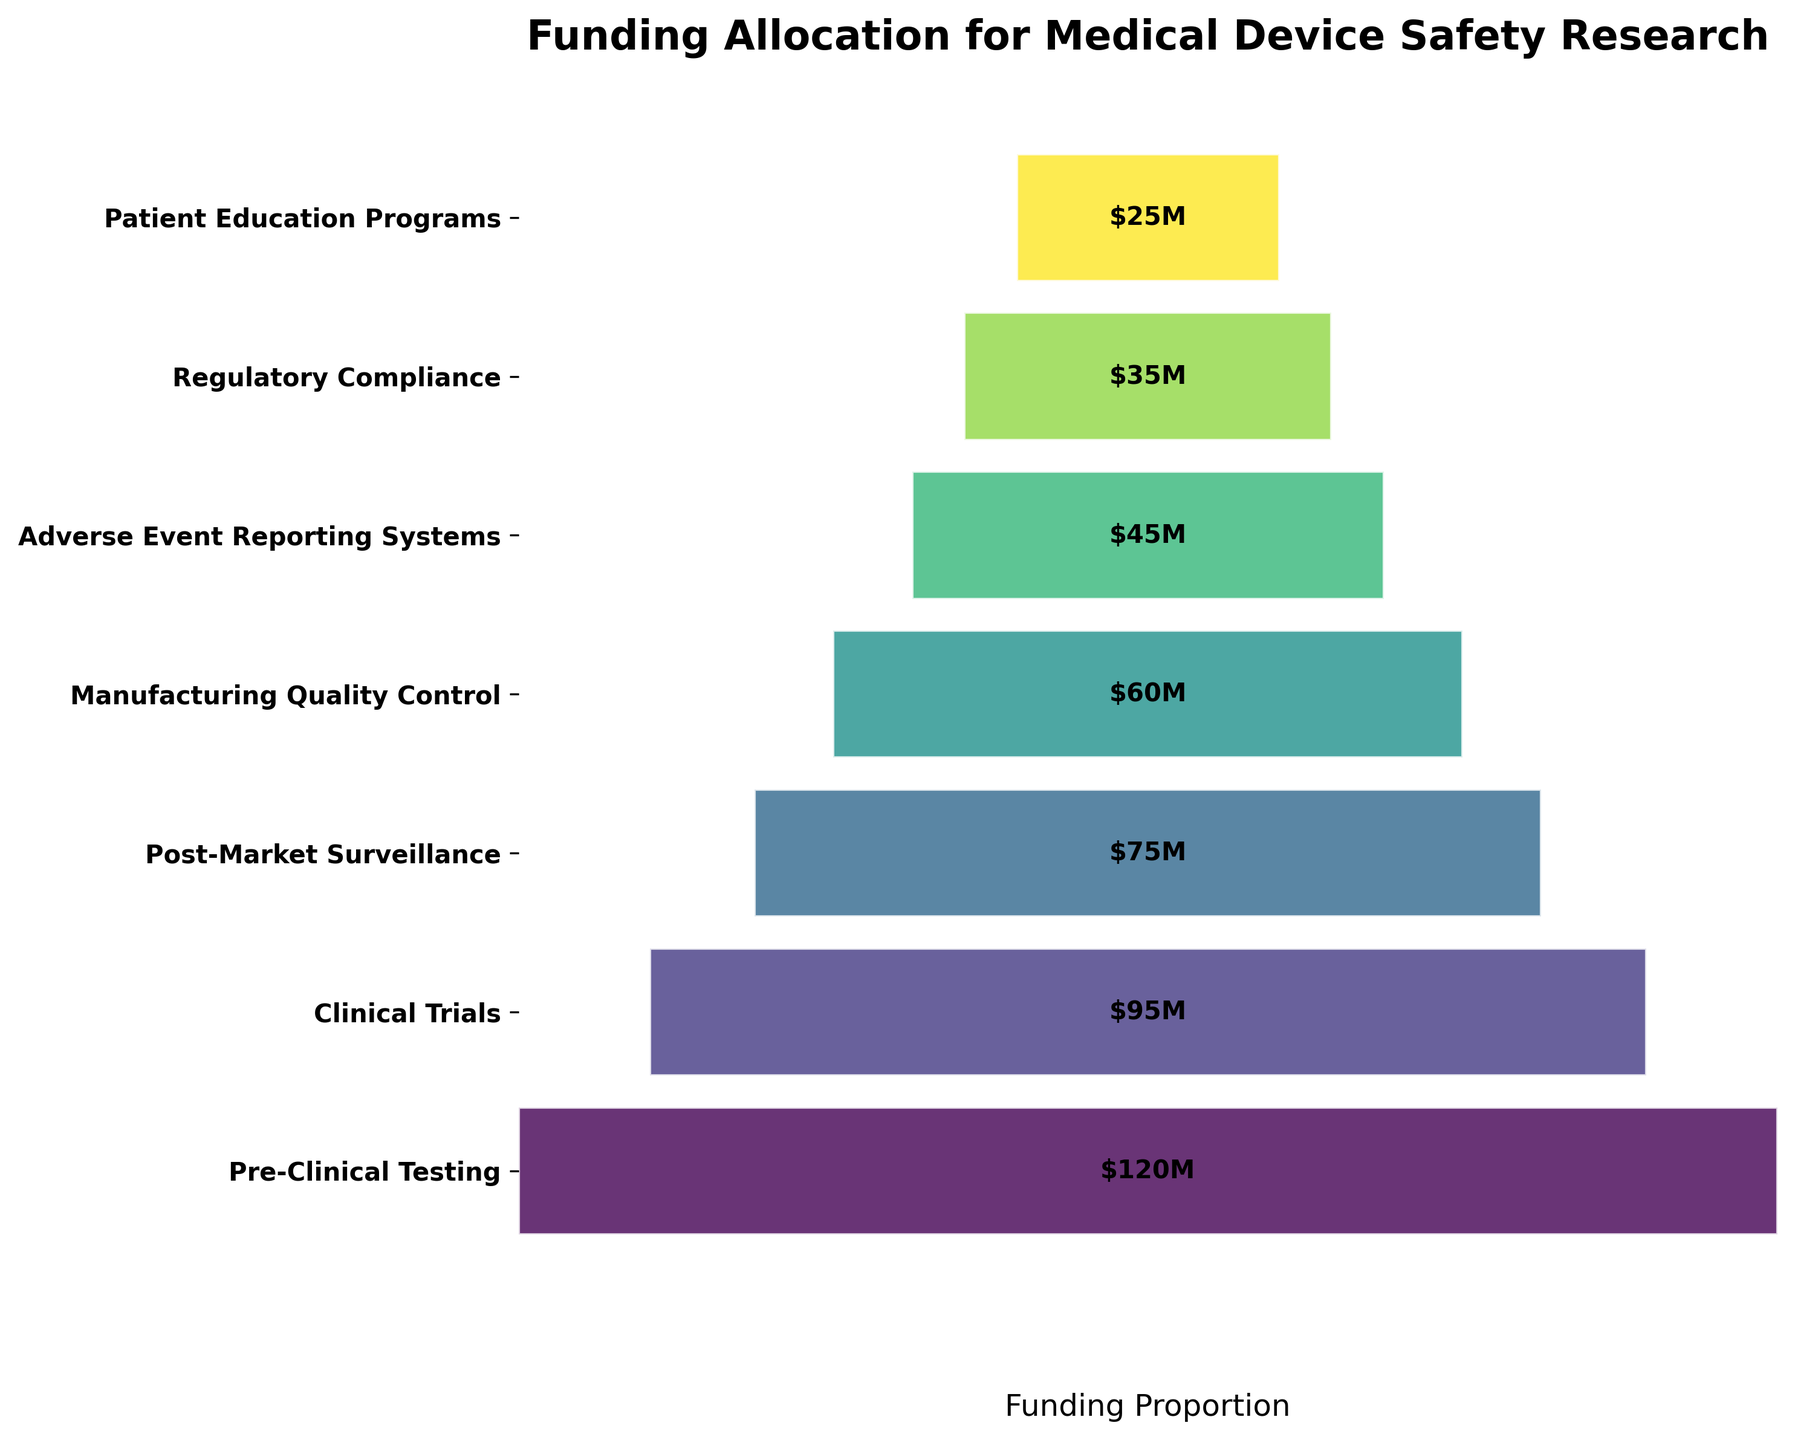What is the title of the figure? The title is usually displayed at the top of the figure. In this case, the title reads "Funding Allocation for Medical Device Safety Research".
Answer: Funding Allocation for Medical Device Safety Research How much funding is allocated for Pre-Clinical Testing? By examining the figure, you can see that Pre-Clinical Testing has a funding allocation labeled directly on the bar. It shows "$120M".
Answer: $120M Which phase has the least amount of funding allocated? Look at the bar with the smallest width and check its label. The smallest bar corresponds to "Patient Education Programs" with a funding of "$25M".
Answer: Patient Education Programs How much more funding is given to Clinical Trials compared to Patient Education Programs? Subtract the funding of Patient Education Programs ($25M) from Clinical Trials ($95M): 95 - 25 is equal to 70.
Answer: $70M Which phases have a funding allocation greater than $50M? Identify bars with values greater than $50M and read the labels. These are "Pre-Clinical Testing" ($120M), "Clinical Trials" ($95M), "Post-Market Surveillance" ($75M), and "Manufacturing Quality Control" ($60M).
Answer: Pre-Clinical Testing, Clinical Trials, Post-Market Surveillance, Manufacturing Quality Control What is the average funding across all phases? First, sum up all the funding values: 120 + 95 + 75 + 60 + 45 + 35 + 25 = 455. Then, divide by the number of phases (7): 455 / 7 = 65.
Answer: $65M Which two phases have a combined funding closest to $100M? Check combinations of funding values to find the pair closest to $100M. "Manufacturing Quality Control" ($60M) and "Adverse Event Reporting Systems" ($45M) sum up to 60 + 45 = 105, which is close to $100M.
Answer: Manufacturing Quality Control and Adverse Event Reporting Systems What is the funding difference between the phase with the highest funding and the phase with the lowest funding? Subtract the lowest funding ($25M for Patient Education Programs) from the highest funding ($120M for Pre-Clinical Testing): 120 - 25 = 95.
Answer: $95M Which phase is second highest in terms of funding? By visually examining the bars from largest to smallest, the second largest bar is for Clinical Trials with $95M.
Answer: Clinical Trials How many phases have funding below the average? From the previous calculation, we know the average is $65M. Count the phases with funding below this amount: "Manufacturing Quality Control" ($60M), "Adverse Event Reporting Systems" ($45M), "Regulatory Compliance" ($35M), and "Patient Education Programs" ($25M). That's 4 phases.
Answer: 4 